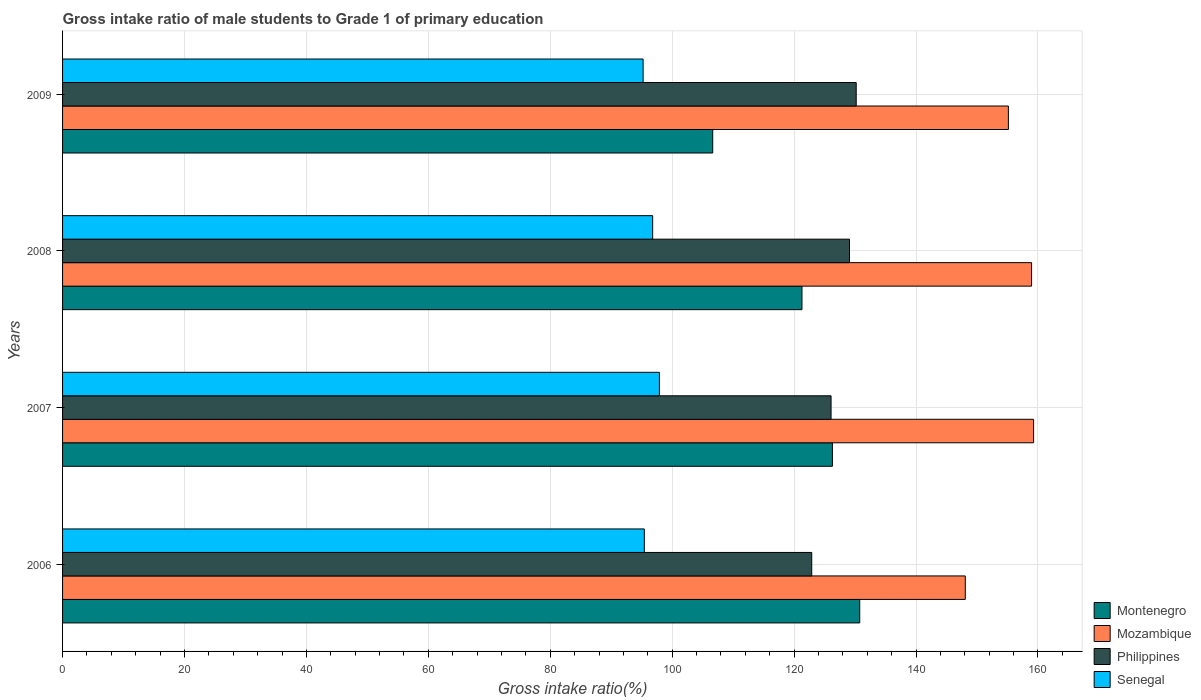Are the number of bars on each tick of the Y-axis equal?
Keep it short and to the point. Yes. How many bars are there on the 1st tick from the top?
Offer a terse response. 4. How many bars are there on the 2nd tick from the bottom?
Offer a terse response. 4. In how many cases, is the number of bars for a given year not equal to the number of legend labels?
Provide a short and direct response. 0. What is the gross intake ratio in Mozambique in 2009?
Ensure brevity in your answer.  155.15. Across all years, what is the maximum gross intake ratio in Senegal?
Your answer should be very brief. 97.9. Across all years, what is the minimum gross intake ratio in Senegal?
Keep it short and to the point. 95.23. In which year was the gross intake ratio in Mozambique maximum?
Your response must be concise. 2007. In which year was the gross intake ratio in Senegal minimum?
Give a very brief answer. 2009. What is the total gross intake ratio in Philippines in the graph?
Your answer should be very brief. 508.23. What is the difference between the gross intake ratio in Senegal in 2006 and that in 2009?
Make the answer very short. 0.2. What is the difference between the gross intake ratio in Philippines in 2006 and the gross intake ratio in Senegal in 2007?
Your response must be concise. 24.99. What is the average gross intake ratio in Senegal per year?
Ensure brevity in your answer.  96.34. In the year 2008, what is the difference between the gross intake ratio in Mozambique and gross intake ratio in Senegal?
Keep it short and to the point. 62.16. In how many years, is the gross intake ratio in Montenegro greater than 4 %?
Ensure brevity in your answer.  4. What is the ratio of the gross intake ratio in Montenegro in 2006 to that in 2009?
Offer a terse response. 1.23. What is the difference between the highest and the second highest gross intake ratio in Montenegro?
Your answer should be compact. 4.48. What is the difference between the highest and the lowest gross intake ratio in Mozambique?
Provide a succinct answer. 11.21. Is the sum of the gross intake ratio in Senegal in 2006 and 2007 greater than the maximum gross intake ratio in Philippines across all years?
Provide a short and direct response. Yes. What does the 1st bar from the top in 2007 represents?
Your answer should be compact. Senegal. How many bars are there?
Provide a short and direct response. 16. Are all the bars in the graph horizontal?
Your answer should be very brief. Yes. Does the graph contain any zero values?
Provide a succinct answer. No. Does the graph contain grids?
Make the answer very short. Yes. Where does the legend appear in the graph?
Offer a very short reply. Bottom right. What is the title of the graph?
Give a very brief answer. Gross intake ratio of male students to Grade 1 of primary education. Does "Congo (Democratic)" appear as one of the legend labels in the graph?
Offer a terse response. No. What is the label or title of the X-axis?
Your answer should be compact. Gross intake ratio(%). What is the label or title of the Y-axis?
Your answer should be very brief. Years. What is the Gross intake ratio(%) of Montenegro in 2006?
Make the answer very short. 130.77. What is the Gross intake ratio(%) of Mozambique in 2006?
Your answer should be compact. 148.08. What is the Gross intake ratio(%) in Philippines in 2006?
Make the answer very short. 122.89. What is the Gross intake ratio(%) of Senegal in 2006?
Your answer should be very brief. 95.43. What is the Gross intake ratio(%) in Montenegro in 2007?
Your answer should be compact. 126.28. What is the Gross intake ratio(%) in Mozambique in 2007?
Ensure brevity in your answer.  159.29. What is the Gross intake ratio(%) in Philippines in 2007?
Offer a terse response. 126.06. What is the Gross intake ratio(%) in Senegal in 2007?
Give a very brief answer. 97.9. What is the Gross intake ratio(%) of Montenegro in 2008?
Your answer should be compact. 121.29. What is the Gross intake ratio(%) of Mozambique in 2008?
Offer a terse response. 158.95. What is the Gross intake ratio(%) of Philippines in 2008?
Your answer should be very brief. 129.09. What is the Gross intake ratio(%) in Senegal in 2008?
Ensure brevity in your answer.  96.8. What is the Gross intake ratio(%) in Montenegro in 2009?
Your answer should be very brief. 106.65. What is the Gross intake ratio(%) of Mozambique in 2009?
Your answer should be compact. 155.15. What is the Gross intake ratio(%) in Philippines in 2009?
Ensure brevity in your answer.  130.19. What is the Gross intake ratio(%) of Senegal in 2009?
Provide a short and direct response. 95.23. Across all years, what is the maximum Gross intake ratio(%) in Montenegro?
Give a very brief answer. 130.77. Across all years, what is the maximum Gross intake ratio(%) of Mozambique?
Offer a very short reply. 159.29. Across all years, what is the maximum Gross intake ratio(%) of Philippines?
Your response must be concise. 130.19. Across all years, what is the maximum Gross intake ratio(%) of Senegal?
Your answer should be compact. 97.9. Across all years, what is the minimum Gross intake ratio(%) in Montenegro?
Keep it short and to the point. 106.65. Across all years, what is the minimum Gross intake ratio(%) of Mozambique?
Provide a short and direct response. 148.08. Across all years, what is the minimum Gross intake ratio(%) in Philippines?
Make the answer very short. 122.89. Across all years, what is the minimum Gross intake ratio(%) in Senegal?
Give a very brief answer. 95.23. What is the total Gross intake ratio(%) in Montenegro in the graph?
Your answer should be compact. 484.99. What is the total Gross intake ratio(%) of Mozambique in the graph?
Give a very brief answer. 621.47. What is the total Gross intake ratio(%) of Philippines in the graph?
Offer a very short reply. 508.23. What is the total Gross intake ratio(%) in Senegal in the graph?
Your answer should be compact. 385.36. What is the difference between the Gross intake ratio(%) in Montenegro in 2006 and that in 2007?
Keep it short and to the point. 4.48. What is the difference between the Gross intake ratio(%) in Mozambique in 2006 and that in 2007?
Provide a succinct answer. -11.21. What is the difference between the Gross intake ratio(%) of Philippines in 2006 and that in 2007?
Keep it short and to the point. -3.17. What is the difference between the Gross intake ratio(%) in Senegal in 2006 and that in 2007?
Keep it short and to the point. -2.47. What is the difference between the Gross intake ratio(%) in Montenegro in 2006 and that in 2008?
Your answer should be compact. 9.47. What is the difference between the Gross intake ratio(%) of Mozambique in 2006 and that in 2008?
Make the answer very short. -10.88. What is the difference between the Gross intake ratio(%) of Philippines in 2006 and that in 2008?
Give a very brief answer. -6.19. What is the difference between the Gross intake ratio(%) in Senegal in 2006 and that in 2008?
Ensure brevity in your answer.  -1.37. What is the difference between the Gross intake ratio(%) of Montenegro in 2006 and that in 2009?
Give a very brief answer. 24.12. What is the difference between the Gross intake ratio(%) in Mozambique in 2006 and that in 2009?
Your response must be concise. -7.07. What is the difference between the Gross intake ratio(%) of Philippines in 2006 and that in 2009?
Give a very brief answer. -7.29. What is the difference between the Gross intake ratio(%) of Senegal in 2006 and that in 2009?
Provide a short and direct response. 0.2. What is the difference between the Gross intake ratio(%) of Montenegro in 2007 and that in 2008?
Ensure brevity in your answer.  4.99. What is the difference between the Gross intake ratio(%) in Mozambique in 2007 and that in 2008?
Your answer should be compact. 0.33. What is the difference between the Gross intake ratio(%) in Philippines in 2007 and that in 2008?
Keep it short and to the point. -3.02. What is the difference between the Gross intake ratio(%) in Senegal in 2007 and that in 2008?
Offer a very short reply. 1.1. What is the difference between the Gross intake ratio(%) in Montenegro in 2007 and that in 2009?
Your answer should be compact. 19.63. What is the difference between the Gross intake ratio(%) of Mozambique in 2007 and that in 2009?
Make the answer very short. 4.14. What is the difference between the Gross intake ratio(%) in Philippines in 2007 and that in 2009?
Provide a short and direct response. -4.12. What is the difference between the Gross intake ratio(%) of Senegal in 2007 and that in 2009?
Give a very brief answer. 2.67. What is the difference between the Gross intake ratio(%) of Montenegro in 2008 and that in 2009?
Your answer should be compact. 14.64. What is the difference between the Gross intake ratio(%) in Mozambique in 2008 and that in 2009?
Make the answer very short. 3.81. What is the difference between the Gross intake ratio(%) in Philippines in 2008 and that in 2009?
Offer a terse response. -1.1. What is the difference between the Gross intake ratio(%) of Senegal in 2008 and that in 2009?
Your answer should be very brief. 1.57. What is the difference between the Gross intake ratio(%) in Montenegro in 2006 and the Gross intake ratio(%) in Mozambique in 2007?
Make the answer very short. -28.52. What is the difference between the Gross intake ratio(%) in Montenegro in 2006 and the Gross intake ratio(%) in Philippines in 2007?
Provide a short and direct response. 4.7. What is the difference between the Gross intake ratio(%) in Montenegro in 2006 and the Gross intake ratio(%) in Senegal in 2007?
Offer a very short reply. 32.86. What is the difference between the Gross intake ratio(%) in Mozambique in 2006 and the Gross intake ratio(%) in Philippines in 2007?
Your answer should be compact. 22.02. What is the difference between the Gross intake ratio(%) of Mozambique in 2006 and the Gross intake ratio(%) of Senegal in 2007?
Give a very brief answer. 50.18. What is the difference between the Gross intake ratio(%) of Philippines in 2006 and the Gross intake ratio(%) of Senegal in 2007?
Your answer should be very brief. 24.99. What is the difference between the Gross intake ratio(%) of Montenegro in 2006 and the Gross intake ratio(%) of Mozambique in 2008?
Give a very brief answer. -28.19. What is the difference between the Gross intake ratio(%) of Montenegro in 2006 and the Gross intake ratio(%) of Philippines in 2008?
Offer a very short reply. 1.68. What is the difference between the Gross intake ratio(%) of Montenegro in 2006 and the Gross intake ratio(%) of Senegal in 2008?
Offer a terse response. 33.97. What is the difference between the Gross intake ratio(%) in Mozambique in 2006 and the Gross intake ratio(%) in Philippines in 2008?
Your answer should be very brief. 18.99. What is the difference between the Gross intake ratio(%) of Mozambique in 2006 and the Gross intake ratio(%) of Senegal in 2008?
Offer a terse response. 51.28. What is the difference between the Gross intake ratio(%) of Philippines in 2006 and the Gross intake ratio(%) of Senegal in 2008?
Your answer should be very brief. 26.09. What is the difference between the Gross intake ratio(%) of Montenegro in 2006 and the Gross intake ratio(%) of Mozambique in 2009?
Keep it short and to the point. -24.38. What is the difference between the Gross intake ratio(%) of Montenegro in 2006 and the Gross intake ratio(%) of Philippines in 2009?
Provide a short and direct response. 0.58. What is the difference between the Gross intake ratio(%) in Montenegro in 2006 and the Gross intake ratio(%) in Senegal in 2009?
Provide a short and direct response. 35.53. What is the difference between the Gross intake ratio(%) of Mozambique in 2006 and the Gross intake ratio(%) of Philippines in 2009?
Provide a short and direct response. 17.89. What is the difference between the Gross intake ratio(%) of Mozambique in 2006 and the Gross intake ratio(%) of Senegal in 2009?
Offer a very short reply. 52.85. What is the difference between the Gross intake ratio(%) in Philippines in 2006 and the Gross intake ratio(%) in Senegal in 2009?
Offer a very short reply. 27.66. What is the difference between the Gross intake ratio(%) in Montenegro in 2007 and the Gross intake ratio(%) in Mozambique in 2008?
Your answer should be compact. -32.67. What is the difference between the Gross intake ratio(%) in Montenegro in 2007 and the Gross intake ratio(%) in Philippines in 2008?
Provide a short and direct response. -2.8. What is the difference between the Gross intake ratio(%) in Montenegro in 2007 and the Gross intake ratio(%) in Senegal in 2008?
Your response must be concise. 29.48. What is the difference between the Gross intake ratio(%) of Mozambique in 2007 and the Gross intake ratio(%) of Philippines in 2008?
Make the answer very short. 30.2. What is the difference between the Gross intake ratio(%) of Mozambique in 2007 and the Gross intake ratio(%) of Senegal in 2008?
Give a very brief answer. 62.49. What is the difference between the Gross intake ratio(%) in Philippines in 2007 and the Gross intake ratio(%) in Senegal in 2008?
Offer a terse response. 29.26. What is the difference between the Gross intake ratio(%) in Montenegro in 2007 and the Gross intake ratio(%) in Mozambique in 2009?
Your response must be concise. -28.87. What is the difference between the Gross intake ratio(%) in Montenegro in 2007 and the Gross intake ratio(%) in Philippines in 2009?
Give a very brief answer. -3.9. What is the difference between the Gross intake ratio(%) of Montenegro in 2007 and the Gross intake ratio(%) of Senegal in 2009?
Provide a short and direct response. 31.05. What is the difference between the Gross intake ratio(%) in Mozambique in 2007 and the Gross intake ratio(%) in Philippines in 2009?
Ensure brevity in your answer.  29.1. What is the difference between the Gross intake ratio(%) of Mozambique in 2007 and the Gross intake ratio(%) of Senegal in 2009?
Offer a terse response. 64.05. What is the difference between the Gross intake ratio(%) in Philippines in 2007 and the Gross intake ratio(%) in Senegal in 2009?
Offer a very short reply. 30.83. What is the difference between the Gross intake ratio(%) of Montenegro in 2008 and the Gross intake ratio(%) of Mozambique in 2009?
Your response must be concise. -33.86. What is the difference between the Gross intake ratio(%) of Montenegro in 2008 and the Gross intake ratio(%) of Philippines in 2009?
Offer a very short reply. -8.9. What is the difference between the Gross intake ratio(%) in Montenegro in 2008 and the Gross intake ratio(%) in Senegal in 2009?
Give a very brief answer. 26.06. What is the difference between the Gross intake ratio(%) in Mozambique in 2008 and the Gross intake ratio(%) in Philippines in 2009?
Provide a succinct answer. 28.77. What is the difference between the Gross intake ratio(%) of Mozambique in 2008 and the Gross intake ratio(%) of Senegal in 2009?
Give a very brief answer. 63.72. What is the difference between the Gross intake ratio(%) in Philippines in 2008 and the Gross intake ratio(%) in Senegal in 2009?
Make the answer very short. 33.85. What is the average Gross intake ratio(%) of Montenegro per year?
Make the answer very short. 121.25. What is the average Gross intake ratio(%) in Mozambique per year?
Offer a very short reply. 155.37. What is the average Gross intake ratio(%) of Philippines per year?
Provide a succinct answer. 127.06. What is the average Gross intake ratio(%) of Senegal per year?
Keep it short and to the point. 96.34. In the year 2006, what is the difference between the Gross intake ratio(%) in Montenegro and Gross intake ratio(%) in Mozambique?
Your answer should be compact. -17.31. In the year 2006, what is the difference between the Gross intake ratio(%) of Montenegro and Gross intake ratio(%) of Philippines?
Keep it short and to the point. 7.87. In the year 2006, what is the difference between the Gross intake ratio(%) in Montenegro and Gross intake ratio(%) in Senegal?
Provide a short and direct response. 35.33. In the year 2006, what is the difference between the Gross intake ratio(%) in Mozambique and Gross intake ratio(%) in Philippines?
Offer a very short reply. 25.19. In the year 2006, what is the difference between the Gross intake ratio(%) of Mozambique and Gross intake ratio(%) of Senegal?
Provide a short and direct response. 52.65. In the year 2006, what is the difference between the Gross intake ratio(%) of Philippines and Gross intake ratio(%) of Senegal?
Your answer should be very brief. 27.46. In the year 2007, what is the difference between the Gross intake ratio(%) in Montenegro and Gross intake ratio(%) in Mozambique?
Give a very brief answer. -33. In the year 2007, what is the difference between the Gross intake ratio(%) in Montenegro and Gross intake ratio(%) in Philippines?
Provide a short and direct response. 0.22. In the year 2007, what is the difference between the Gross intake ratio(%) of Montenegro and Gross intake ratio(%) of Senegal?
Your answer should be very brief. 28.38. In the year 2007, what is the difference between the Gross intake ratio(%) in Mozambique and Gross intake ratio(%) in Philippines?
Keep it short and to the point. 33.22. In the year 2007, what is the difference between the Gross intake ratio(%) of Mozambique and Gross intake ratio(%) of Senegal?
Offer a terse response. 61.38. In the year 2007, what is the difference between the Gross intake ratio(%) of Philippines and Gross intake ratio(%) of Senegal?
Keep it short and to the point. 28.16. In the year 2008, what is the difference between the Gross intake ratio(%) in Montenegro and Gross intake ratio(%) in Mozambique?
Make the answer very short. -37.66. In the year 2008, what is the difference between the Gross intake ratio(%) in Montenegro and Gross intake ratio(%) in Philippines?
Ensure brevity in your answer.  -7.79. In the year 2008, what is the difference between the Gross intake ratio(%) of Montenegro and Gross intake ratio(%) of Senegal?
Provide a succinct answer. 24.49. In the year 2008, what is the difference between the Gross intake ratio(%) of Mozambique and Gross intake ratio(%) of Philippines?
Provide a succinct answer. 29.87. In the year 2008, what is the difference between the Gross intake ratio(%) in Mozambique and Gross intake ratio(%) in Senegal?
Give a very brief answer. 62.16. In the year 2008, what is the difference between the Gross intake ratio(%) in Philippines and Gross intake ratio(%) in Senegal?
Your response must be concise. 32.29. In the year 2009, what is the difference between the Gross intake ratio(%) in Montenegro and Gross intake ratio(%) in Mozambique?
Make the answer very short. -48.5. In the year 2009, what is the difference between the Gross intake ratio(%) of Montenegro and Gross intake ratio(%) of Philippines?
Your response must be concise. -23.54. In the year 2009, what is the difference between the Gross intake ratio(%) in Montenegro and Gross intake ratio(%) in Senegal?
Provide a succinct answer. 11.42. In the year 2009, what is the difference between the Gross intake ratio(%) in Mozambique and Gross intake ratio(%) in Philippines?
Make the answer very short. 24.96. In the year 2009, what is the difference between the Gross intake ratio(%) in Mozambique and Gross intake ratio(%) in Senegal?
Your answer should be very brief. 59.92. In the year 2009, what is the difference between the Gross intake ratio(%) of Philippines and Gross intake ratio(%) of Senegal?
Ensure brevity in your answer.  34.96. What is the ratio of the Gross intake ratio(%) of Montenegro in 2006 to that in 2007?
Ensure brevity in your answer.  1.04. What is the ratio of the Gross intake ratio(%) of Mozambique in 2006 to that in 2007?
Make the answer very short. 0.93. What is the ratio of the Gross intake ratio(%) in Philippines in 2006 to that in 2007?
Offer a terse response. 0.97. What is the ratio of the Gross intake ratio(%) in Senegal in 2006 to that in 2007?
Provide a succinct answer. 0.97. What is the ratio of the Gross intake ratio(%) of Montenegro in 2006 to that in 2008?
Make the answer very short. 1.08. What is the ratio of the Gross intake ratio(%) of Mozambique in 2006 to that in 2008?
Ensure brevity in your answer.  0.93. What is the ratio of the Gross intake ratio(%) in Philippines in 2006 to that in 2008?
Your answer should be compact. 0.95. What is the ratio of the Gross intake ratio(%) of Senegal in 2006 to that in 2008?
Make the answer very short. 0.99. What is the ratio of the Gross intake ratio(%) of Montenegro in 2006 to that in 2009?
Offer a very short reply. 1.23. What is the ratio of the Gross intake ratio(%) of Mozambique in 2006 to that in 2009?
Make the answer very short. 0.95. What is the ratio of the Gross intake ratio(%) of Philippines in 2006 to that in 2009?
Your answer should be compact. 0.94. What is the ratio of the Gross intake ratio(%) in Senegal in 2006 to that in 2009?
Your answer should be compact. 1. What is the ratio of the Gross intake ratio(%) of Montenegro in 2007 to that in 2008?
Provide a succinct answer. 1.04. What is the ratio of the Gross intake ratio(%) of Philippines in 2007 to that in 2008?
Your answer should be very brief. 0.98. What is the ratio of the Gross intake ratio(%) in Senegal in 2007 to that in 2008?
Your answer should be very brief. 1.01. What is the ratio of the Gross intake ratio(%) of Montenegro in 2007 to that in 2009?
Offer a very short reply. 1.18. What is the ratio of the Gross intake ratio(%) in Mozambique in 2007 to that in 2009?
Give a very brief answer. 1.03. What is the ratio of the Gross intake ratio(%) of Philippines in 2007 to that in 2009?
Your answer should be compact. 0.97. What is the ratio of the Gross intake ratio(%) in Senegal in 2007 to that in 2009?
Your answer should be compact. 1.03. What is the ratio of the Gross intake ratio(%) in Montenegro in 2008 to that in 2009?
Provide a short and direct response. 1.14. What is the ratio of the Gross intake ratio(%) of Mozambique in 2008 to that in 2009?
Offer a terse response. 1.02. What is the ratio of the Gross intake ratio(%) in Senegal in 2008 to that in 2009?
Your response must be concise. 1.02. What is the difference between the highest and the second highest Gross intake ratio(%) in Montenegro?
Your answer should be very brief. 4.48. What is the difference between the highest and the second highest Gross intake ratio(%) in Mozambique?
Provide a succinct answer. 0.33. What is the difference between the highest and the second highest Gross intake ratio(%) in Philippines?
Your response must be concise. 1.1. What is the difference between the highest and the second highest Gross intake ratio(%) in Senegal?
Your response must be concise. 1.1. What is the difference between the highest and the lowest Gross intake ratio(%) in Montenegro?
Keep it short and to the point. 24.12. What is the difference between the highest and the lowest Gross intake ratio(%) in Mozambique?
Offer a very short reply. 11.21. What is the difference between the highest and the lowest Gross intake ratio(%) of Philippines?
Keep it short and to the point. 7.29. What is the difference between the highest and the lowest Gross intake ratio(%) in Senegal?
Your answer should be compact. 2.67. 